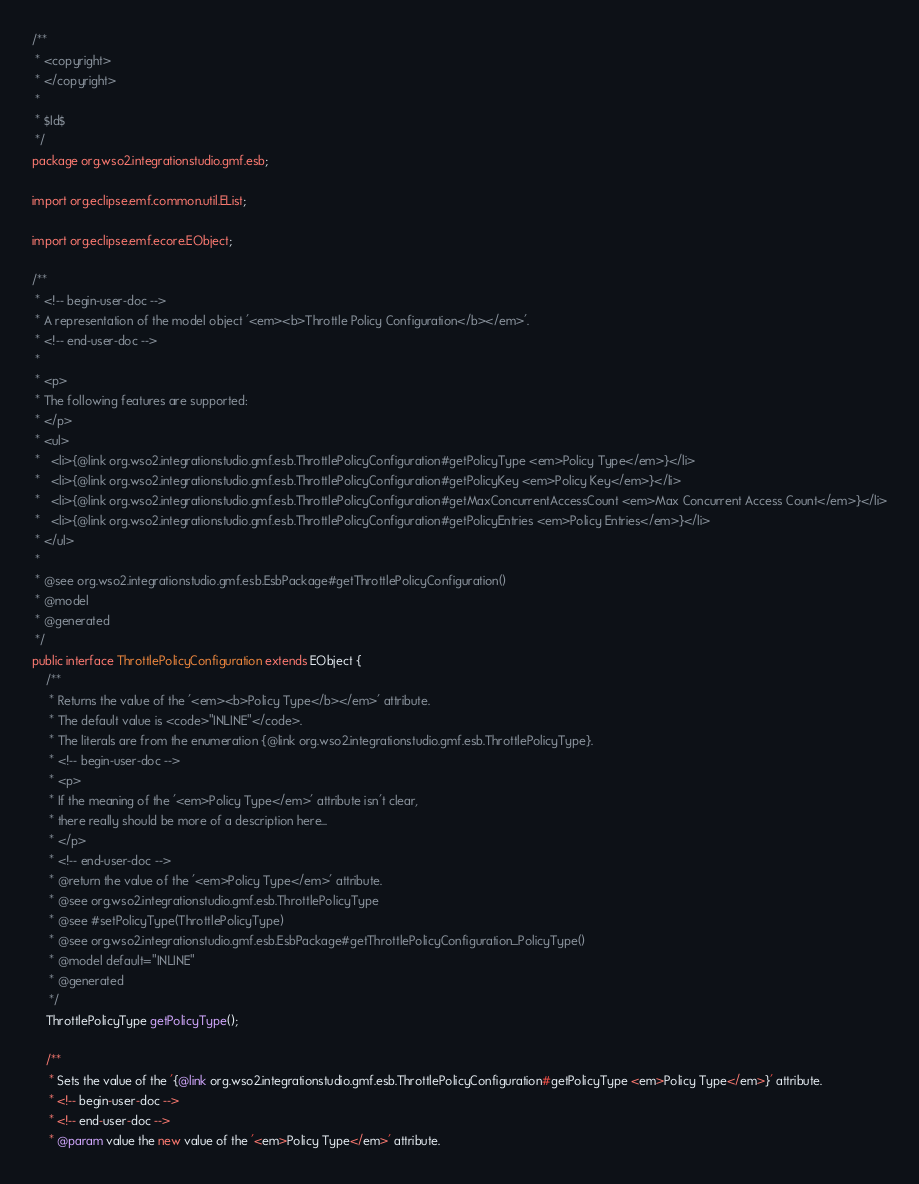Convert code to text. <code><loc_0><loc_0><loc_500><loc_500><_Java_>/**
 * <copyright>
 * </copyright>
 *
 * $Id$
 */
package org.wso2.integrationstudio.gmf.esb;

import org.eclipse.emf.common.util.EList;

import org.eclipse.emf.ecore.EObject;

/**
 * <!-- begin-user-doc -->
 * A representation of the model object '<em><b>Throttle Policy Configuration</b></em>'.
 * <!-- end-user-doc -->
 *
 * <p>
 * The following features are supported:
 * </p>
 * <ul>
 *   <li>{@link org.wso2.integrationstudio.gmf.esb.ThrottlePolicyConfiguration#getPolicyType <em>Policy Type</em>}</li>
 *   <li>{@link org.wso2.integrationstudio.gmf.esb.ThrottlePolicyConfiguration#getPolicyKey <em>Policy Key</em>}</li>
 *   <li>{@link org.wso2.integrationstudio.gmf.esb.ThrottlePolicyConfiguration#getMaxConcurrentAccessCount <em>Max Concurrent Access Count</em>}</li>
 *   <li>{@link org.wso2.integrationstudio.gmf.esb.ThrottlePolicyConfiguration#getPolicyEntries <em>Policy Entries</em>}</li>
 * </ul>
 *
 * @see org.wso2.integrationstudio.gmf.esb.EsbPackage#getThrottlePolicyConfiguration()
 * @model
 * @generated
 */
public interface ThrottlePolicyConfiguration extends EObject {
    /**
     * Returns the value of the '<em><b>Policy Type</b></em>' attribute.
     * The default value is <code>"INLINE"</code>.
     * The literals are from the enumeration {@link org.wso2.integrationstudio.gmf.esb.ThrottlePolicyType}.
     * <!-- begin-user-doc -->
     * <p>
     * If the meaning of the '<em>Policy Type</em>' attribute isn't clear,
     * there really should be more of a description here...
     * </p>
     * <!-- end-user-doc -->
     * @return the value of the '<em>Policy Type</em>' attribute.
     * @see org.wso2.integrationstudio.gmf.esb.ThrottlePolicyType
     * @see #setPolicyType(ThrottlePolicyType)
     * @see org.wso2.integrationstudio.gmf.esb.EsbPackage#getThrottlePolicyConfiguration_PolicyType()
     * @model default="INLINE"
     * @generated
     */
    ThrottlePolicyType getPolicyType();

    /**
     * Sets the value of the '{@link org.wso2.integrationstudio.gmf.esb.ThrottlePolicyConfiguration#getPolicyType <em>Policy Type</em>}' attribute.
     * <!-- begin-user-doc -->
     * <!-- end-user-doc -->
     * @param value the new value of the '<em>Policy Type</em>' attribute.</code> 